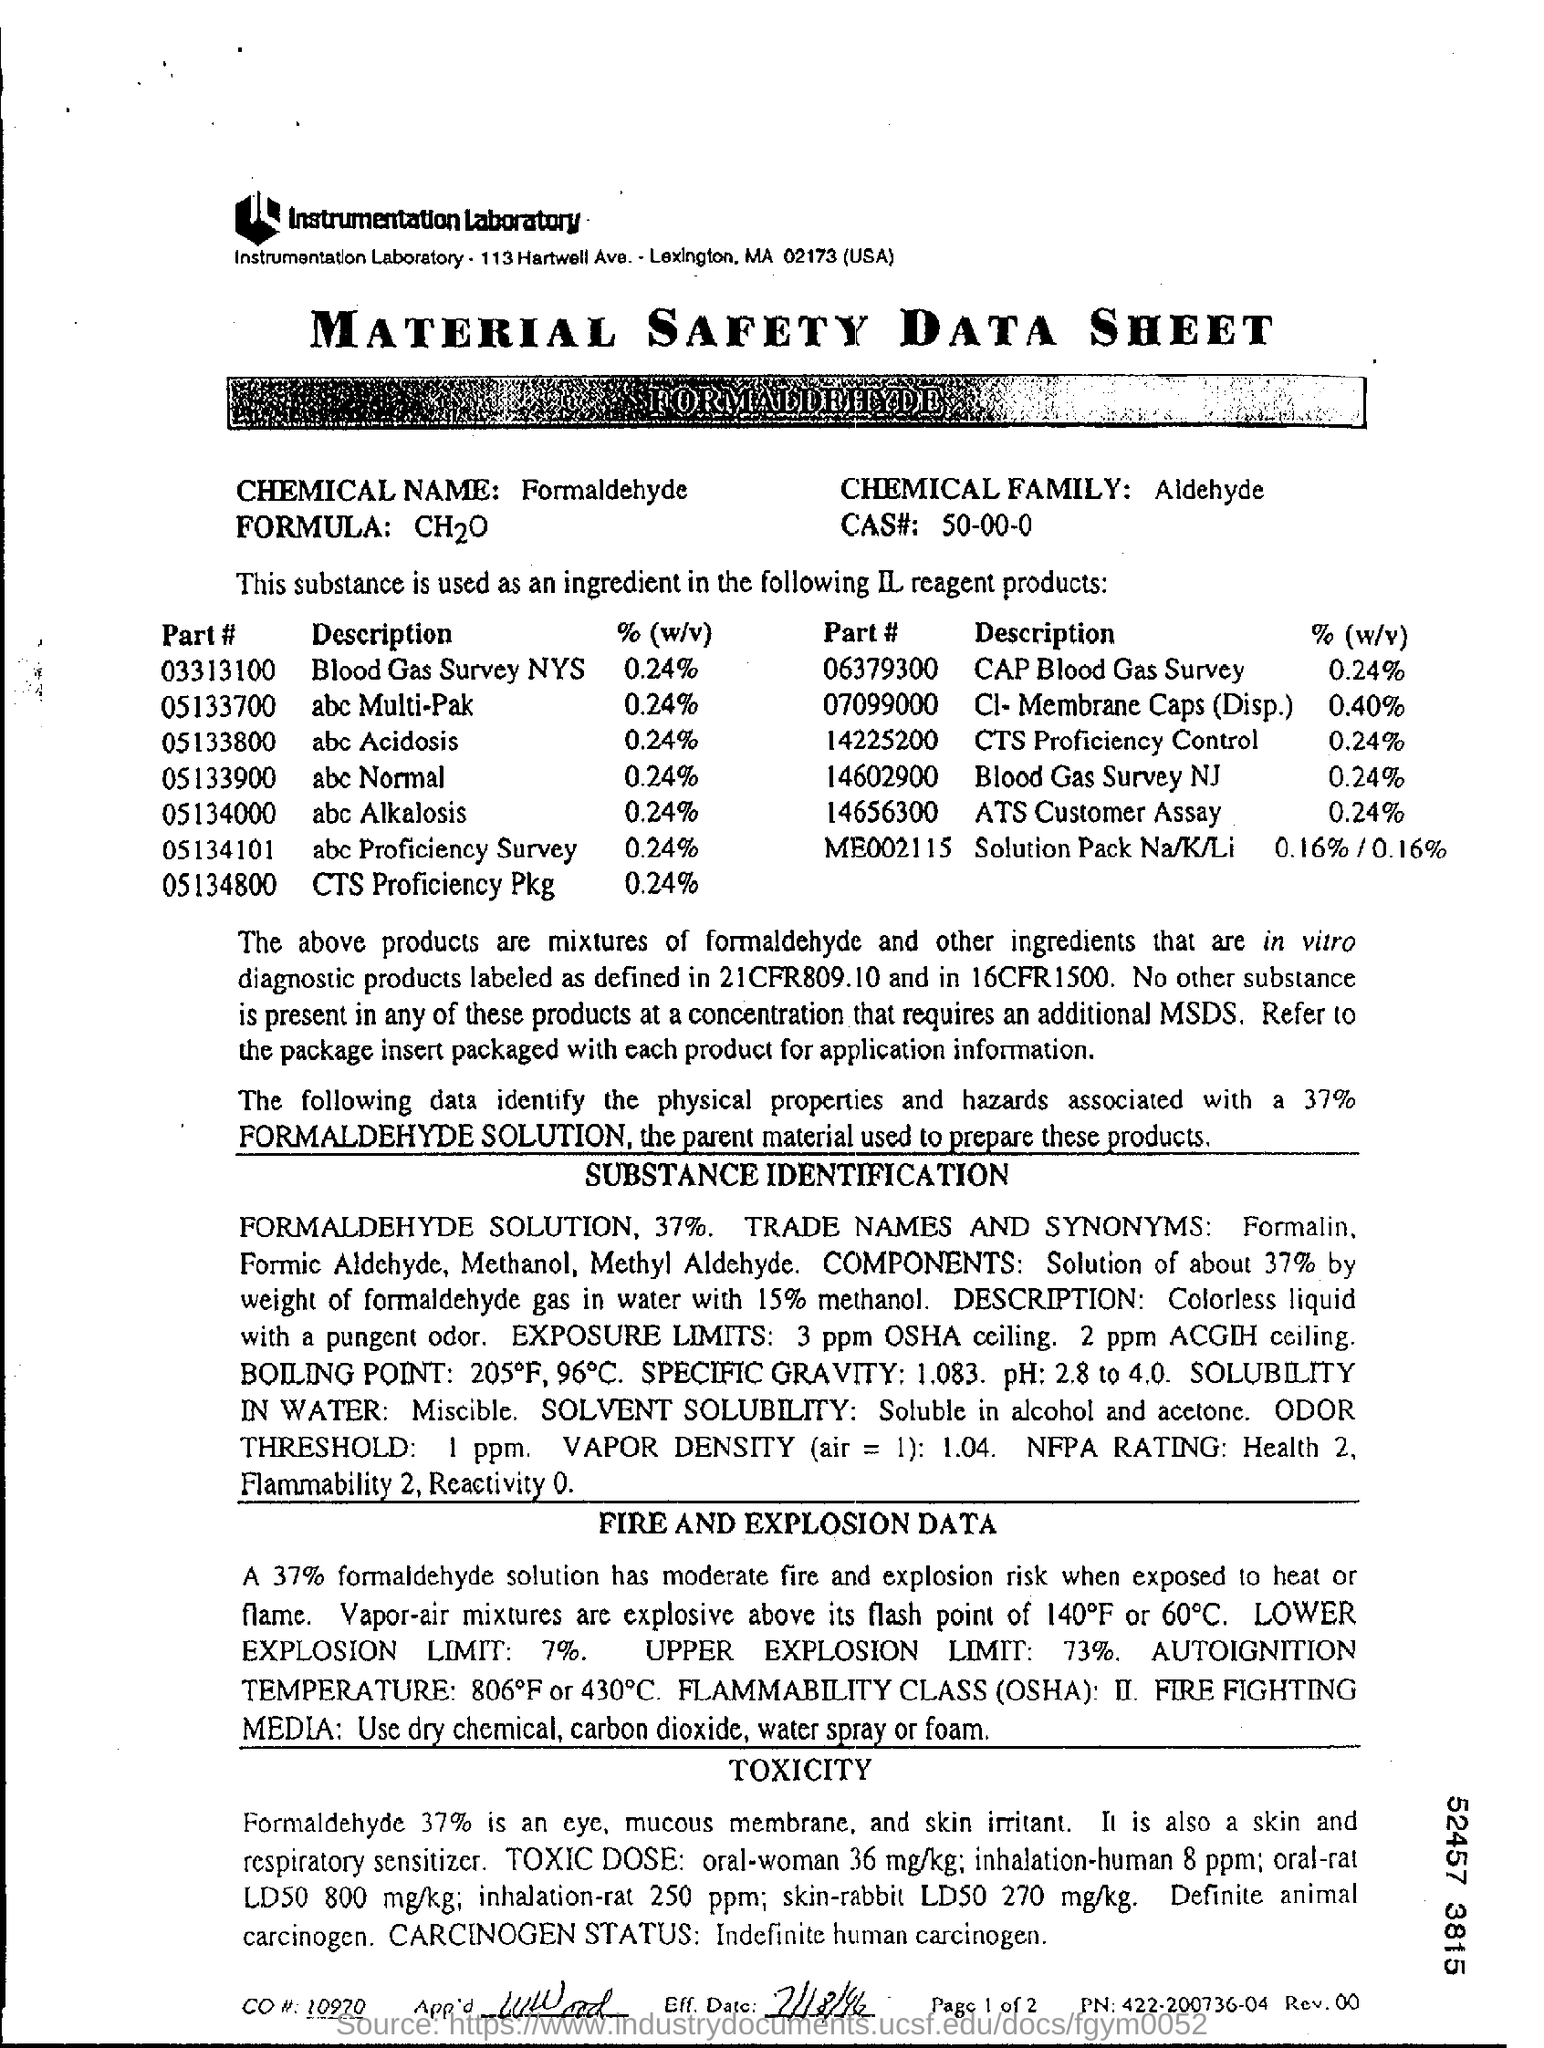What is the description of Part # 05133700?
Provide a succinct answer. Abc multi-pak. What is the %(w/v) of abc Alkalosis?
Give a very brief answer. 0.24. What is the UPPER EXPLOSION LIMIT?
Your answer should be very brief. 73 %. What is the CAS #?
Offer a terse response. 50-00-0. 